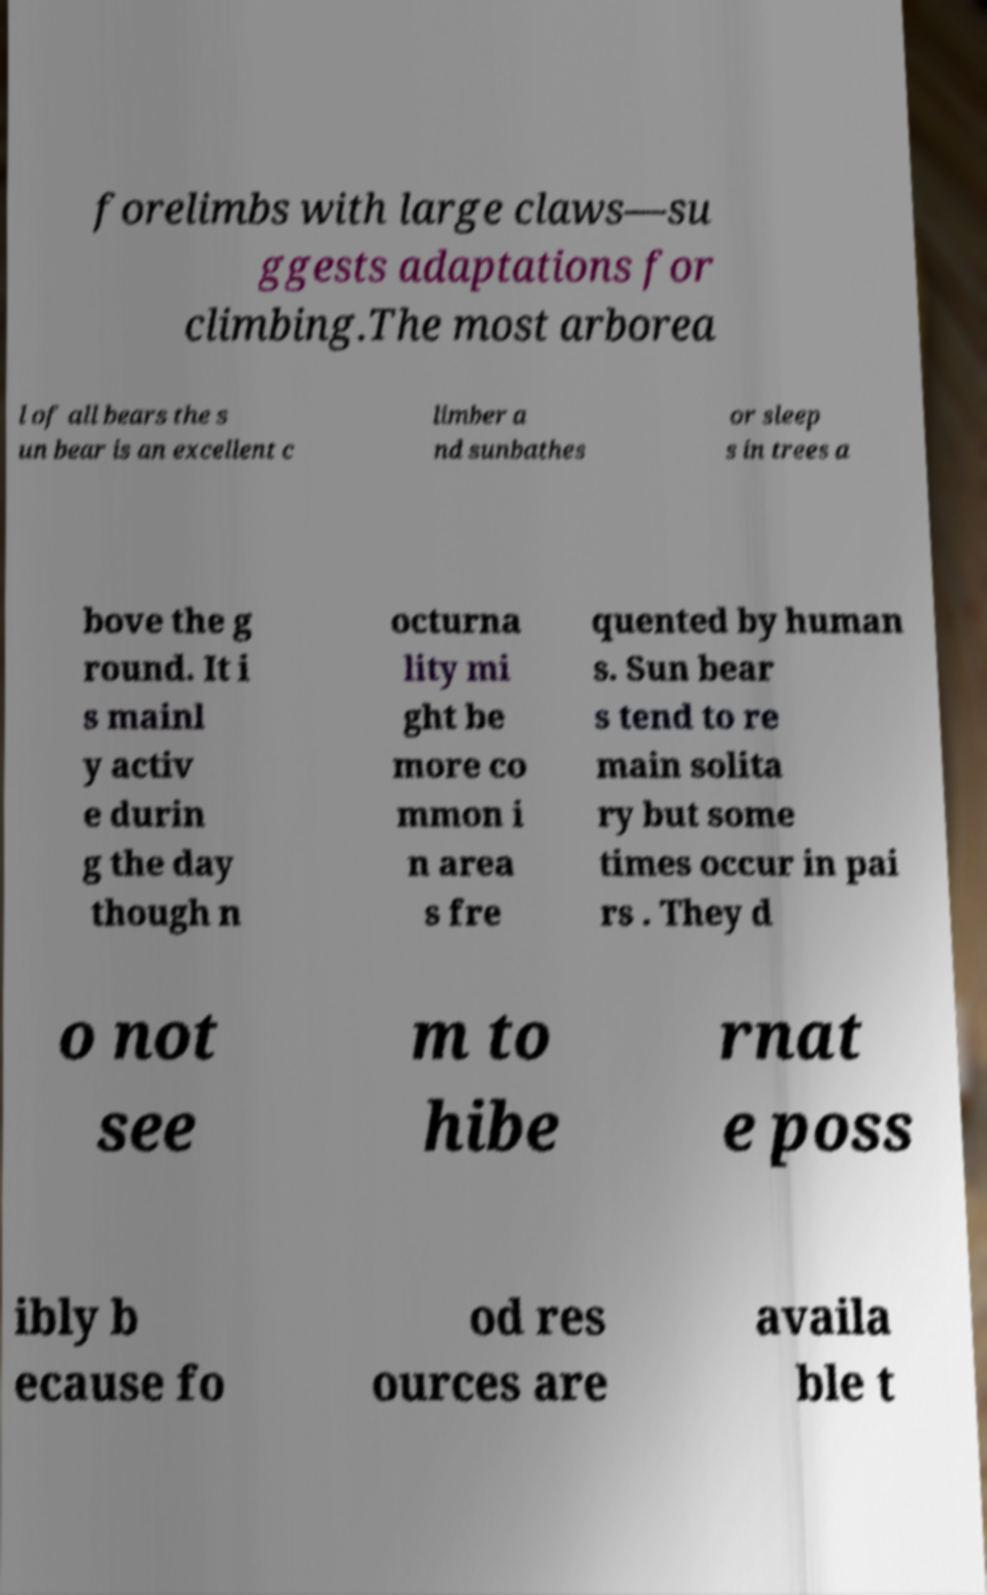There's text embedded in this image that I need extracted. Can you transcribe it verbatim? forelimbs with large claws—su ggests adaptations for climbing.The most arborea l of all bears the s un bear is an excellent c limber a nd sunbathes or sleep s in trees a bove the g round. It i s mainl y activ e durin g the day though n octurna lity mi ght be more co mmon i n area s fre quented by human s. Sun bear s tend to re main solita ry but some times occur in pai rs . They d o not see m to hibe rnat e poss ibly b ecause fo od res ources are availa ble t 